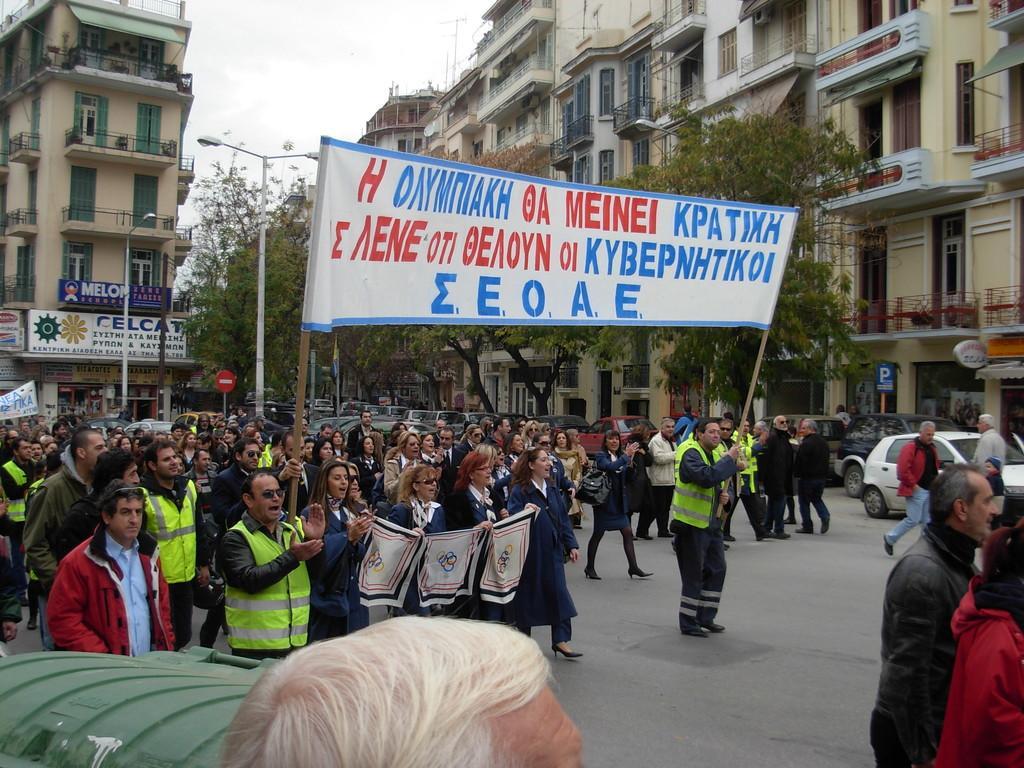In one or two sentences, can you explain what this image depicts? In this image, we can see a group of people. Among them, some are holding banners with some text written on it. We can also see the ground. We can see a few vehicles, trees and poles. We can also see some buildings. We can see the sky. 